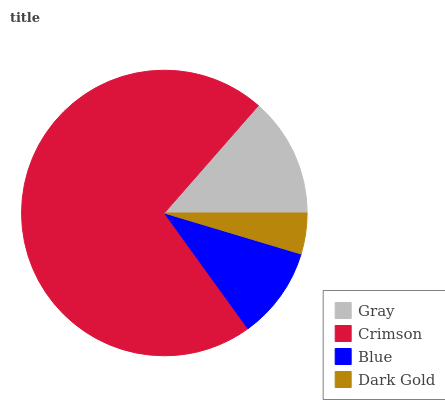Is Dark Gold the minimum?
Answer yes or no. Yes. Is Crimson the maximum?
Answer yes or no. Yes. Is Blue the minimum?
Answer yes or no. No. Is Blue the maximum?
Answer yes or no. No. Is Crimson greater than Blue?
Answer yes or no. Yes. Is Blue less than Crimson?
Answer yes or no. Yes. Is Blue greater than Crimson?
Answer yes or no. No. Is Crimson less than Blue?
Answer yes or no. No. Is Gray the high median?
Answer yes or no. Yes. Is Blue the low median?
Answer yes or no. Yes. Is Crimson the high median?
Answer yes or no. No. Is Dark Gold the low median?
Answer yes or no. No. 